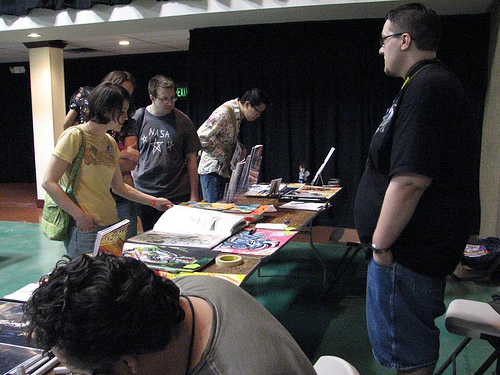<image>
Is there a girl to the right of the guy? Yes. From this viewpoint, the girl is positioned to the right side relative to the guy. 